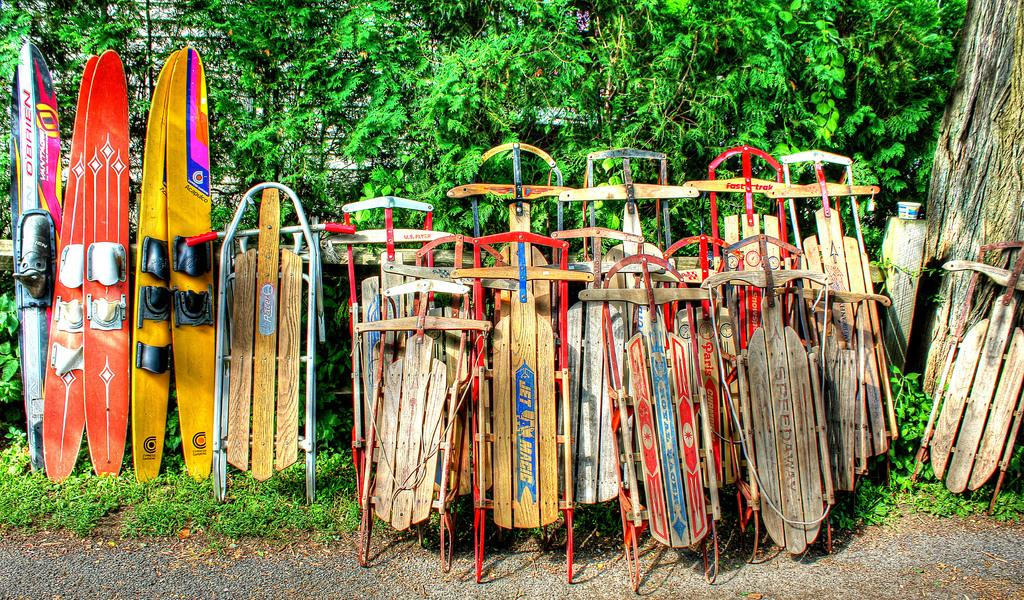What is the main subject in the foreground of the image? There are surfing boats in the foreground of the image. What can be seen in the background of the image? There is greenery in the background of the image. What list of items can be seen in the image? There is no list of items present in the image. Can you tell me the birth date of the person in the image? There is no person in the image, so their birth date cannot be determined. 